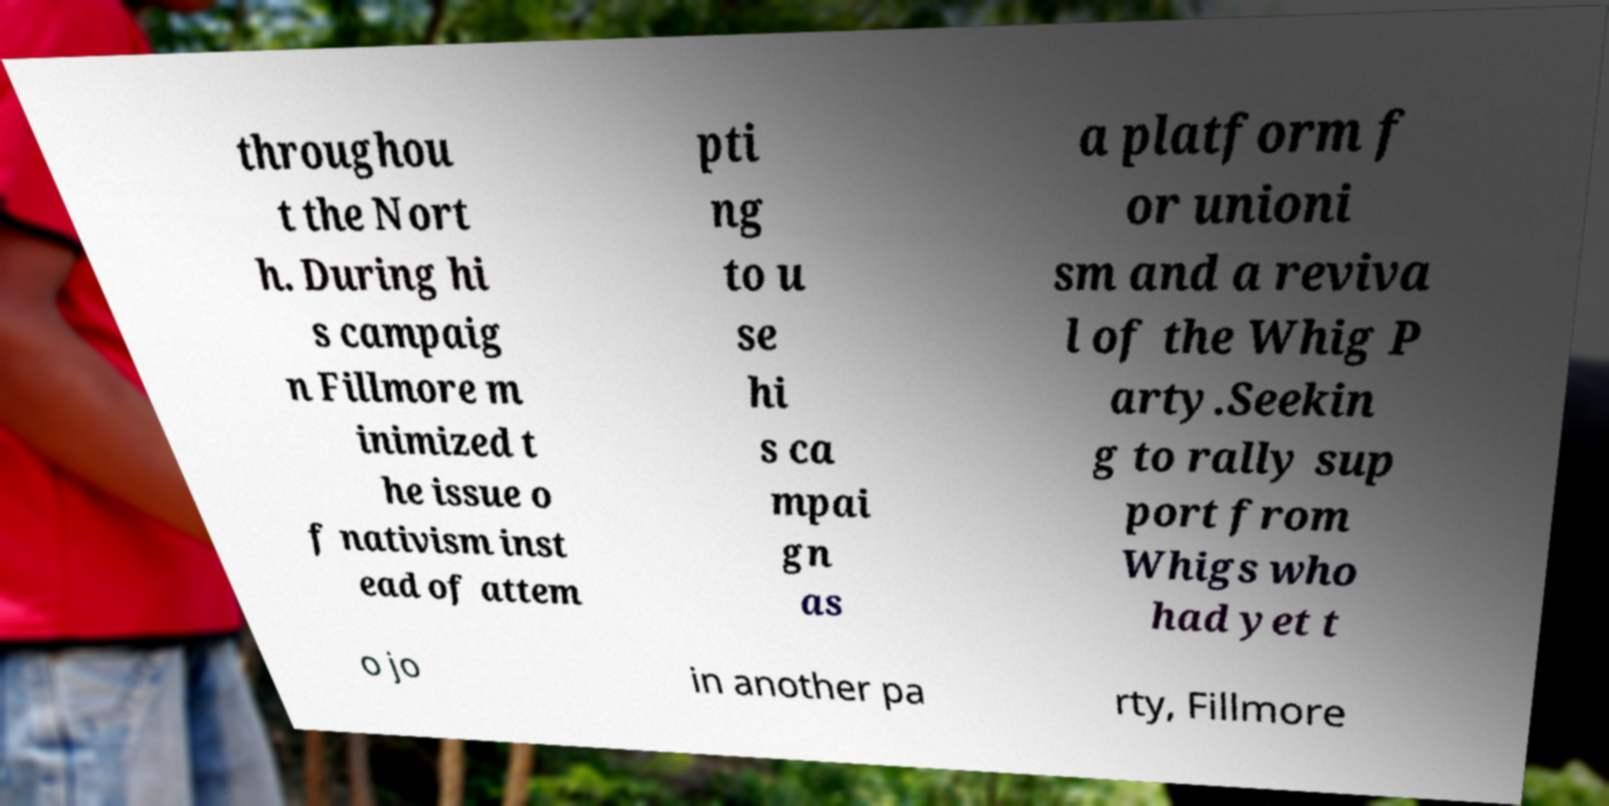Please identify and transcribe the text found in this image. throughou t the Nort h. During hi s campaig n Fillmore m inimized t he issue o f nativism inst ead of attem pti ng to u se hi s ca mpai gn as a platform f or unioni sm and a reviva l of the Whig P arty.Seekin g to rally sup port from Whigs who had yet t o jo in another pa rty, Fillmore 